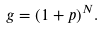Convert formula to latex. <formula><loc_0><loc_0><loc_500><loc_500>g = ( 1 + p ) ^ { N } .</formula> 